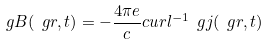Convert formula to latex. <formula><loc_0><loc_0><loc_500><loc_500>\ g { B } ( \ g { r } , t ) = - \frac { 4 \pi e } { c } c u r l ^ { - 1 } \ g { j } ( \ g { r } , t )</formula> 